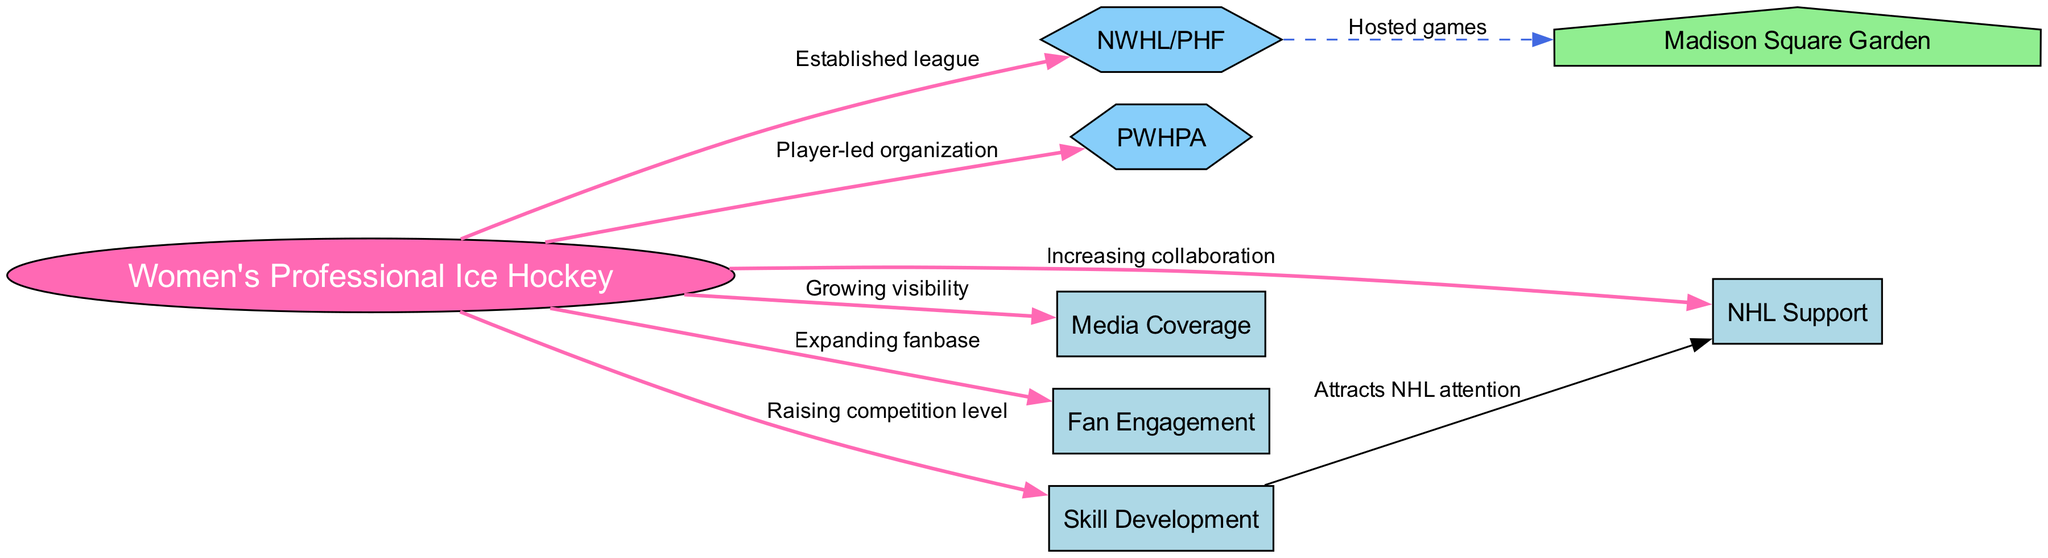What is the central node in the diagram? The central node is identified by its shape (ellipse) and position in the diagram, representing the primary topic, which is "Women's Professional Ice Hockey."
Answer: Women's Professional Ice Hockey How many total nodes are in the diagram? By counting the nodes listed in the diagram data, there are eight distinct nodes indicating different aspects of women's professional ice hockey and its related organizations.
Answer: 8 What relationship exists between Women's Professional Ice Hockey and NWHL/PHF? The edge from "Women's Professional Ice Hockey" to "NWHL/PHF" is labeled "Established league," indicating that the NWHL/PHF is a league formed under the larger umbrella of women's professional ice hockey.
Answer: Established league Which organization focuses on player-led initiatives? The edge connecting "Women's Professional Ice Hockey" and "PWHPA" indicates that the PWHPA is specifically a player-led organization within this context, highlighting its focus on advocating for women's hockey players.
Answer: PWHPA What does "Skill Development" influence in the diagram? The edge illustrates that "Skill Development" raises the competition level of women's professional ice hockey, indicating its role in enhancing player skills within the sport.
Answer: Raising competition level How does "Skill Development" relate to "NHL Support"? The relationship is shown through an edge that states "Attracts NHL attention," suggesting that improvements in skill development within women's hockey lead to greater interest and support from the NHL.
Answer: Attracts NHL attention What factor is associated with increased fan engagement? The edge from "Women's Professional Ice Hockey" to "Fan Engagement" indicates that as women's hockey grows, it expands its fanbase, thereby increasing overall engagement with fans.
Answer: Expanding fanbase What is represented by Madison Square Garden in the context of women's hockey? Madison Square Garden is represented as a venue that has hosted games for the NWHL/PHF, demonstrating its role as a significant location for women's professional hockey events.
Answer: Hosted games 